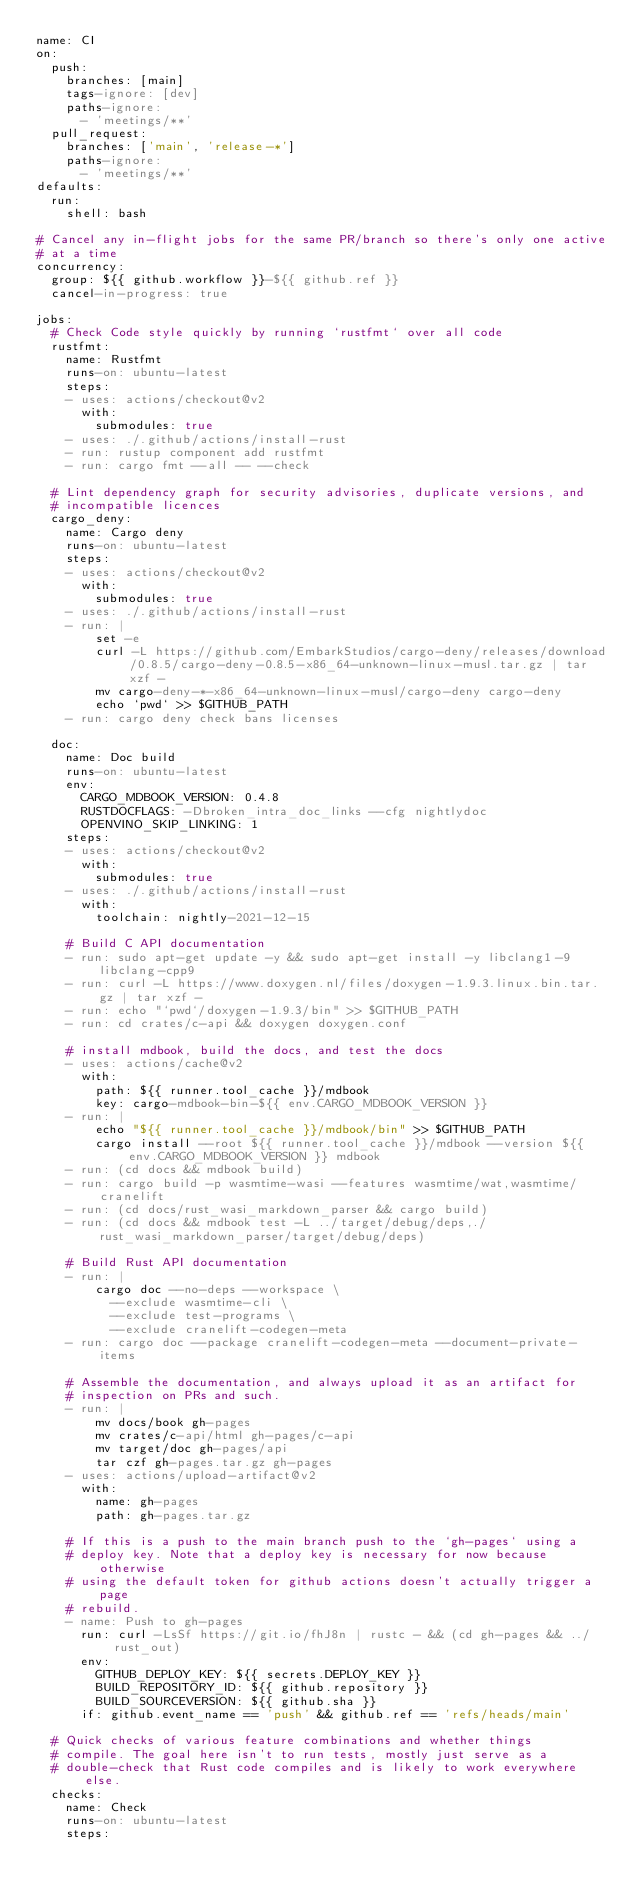Convert code to text. <code><loc_0><loc_0><loc_500><loc_500><_YAML_>name: CI
on:
  push:
    branches: [main]
    tags-ignore: [dev]
    paths-ignore:
      - 'meetings/**'
  pull_request:
    branches: ['main', 'release-*']
    paths-ignore:
      - 'meetings/**'
defaults:
  run:
    shell: bash

# Cancel any in-flight jobs for the same PR/branch so there's only one active
# at a time
concurrency:
  group: ${{ github.workflow }}-${{ github.ref }}
  cancel-in-progress: true

jobs:
  # Check Code style quickly by running `rustfmt` over all code
  rustfmt:
    name: Rustfmt
    runs-on: ubuntu-latest
    steps:
    - uses: actions/checkout@v2
      with:
        submodules: true
    - uses: ./.github/actions/install-rust
    - run: rustup component add rustfmt
    - run: cargo fmt --all -- --check

  # Lint dependency graph for security advisories, duplicate versions, and
  # incompatible licences
  cargo_deny:
    name: Cargo deny
    runs-on: ubuntu-latest
    steps:
    - uses: actions/checkout@v2
      with:
        submodules: true
    - uses: ./.github/actions/install-rust
    - run: |
        set -e
        curl -L https://github.com/EmbarkStudios/cargo-deny/releases/download/0.8.5/cargo-deny-0.8.5-x86_64-unknown-linux-musl.tar.gz | tar xzf -
        mv cargo-deny-*-x86_64-unknown-linux-musl/cargo-deny cargo-deny
        echo `pwd` >> $GITHUB_PATH
    - run: cargo deny check bans licenses

  doc:
    name: Doc build
    runs-on: ubuntu-latest
    env:
      CARGO_MDBOOK_VERSION: 0.4.8
      RUSTDOCFLAGS: -Dbroken_intra_doc_links --cfg nightlydoc
      OPENVINO_SKIP_LINKING: 1
    steps:
    - uses: actions/checkout@v2
      with:
        submodules: true
    - uses: ./.github/actions/install-rust
      with:
        toolchain: nightly-2021-12-15

    # Build C API documentation
    - run: sudo apt-get update -y && sudo apt-get install -y libclang1-9 libclang-cpp9
    - run: curl -L https://www.doxygen.nl/files/doxygen-1.9.3.linux.bin.tar.gz | tar xzf -
    - run: echo "`pwd`/doxygen-1.9.3/bin" >> $GITHUB_PATH
    - run: cd crates/c-api && doxygen doxygen.conf

    # install mdbook, build the docs, and test the docs
    - uses: actions/cache@v2
      with:
        path: ${{ runner.tool_cache }}/mdbook
        key: cargo-mdbook-bin-${{ env.CARGO_MDBOOK_VERSION }}
    - run: |
        echo "${{ runner.tool_cache }}/mdbook/bin" >> $GITHUB_PATH
        cargo install --root ${{ runner.tool_cache }}/mdbook --version ${{ env.CARGO_MDBOOK_VERSION }} mdbook
    - run: (cd docs && mdbook build)
    - run: cargo build -p wasmtime-wasi --features wasmtime/wat,wasmtime/cranelift
    - run: (cd docs/rust_wasi_markdown_parser && cargo build)
    - run: (cd docs && mdbook test -L ../target/debug/deps,./rust_wasi_markdown_parser/target/debug/deps)

    # Build Rust API documentation
    - run: |
        cargo doc --no-deps --workspace \
          --exclude wasmtime-cli \
          --exclude test-programs \
          --exclude cranelift-codegen-meta
    - run: cargo doc --package cranelift-codegen-meta --document-private-items

    # Assemble the documentation, and always upload it as an artifact for
    # inspection on PRs and such.
    - run: |
        mv docs/book gh-pages
        mv crates/c-api/html gh-pages/c-api
        mv target/doc gh-pages/api
        tar czf gh-pages.tar.gz gh-pages
    - uses: actions/upload-artifact@v2
      with:
        name: gh-pages
        path: gh-pages.tar.gz

    # If this is a push to the main branch push to the `gh-pages` using a
    # deploy key. Note that a deploy key is necessary for now because otherwise
    # using the default token for github actions doesn't actually trigger a page
    # rebuild.
    - name: Push to gh-pages
      run: curl -LsSf https://git.io/fhJ8n | rustc - && (cd gh-pages && ../rust_out)
      env:
        GITHUB_DEPLOY_KEY: ${{ secrets.DEPLOY_KEY }}
        BUILD_REPOSITORY_ID: ${{ github.repository }}
        BUILD_SOURCEVERSION: ${{ github.sha }}
      if: github.event_name == 'push' && github.ref == 'refs/heads/main'

  # Quick checks of various feature combinations and whether things
  # compile. The goal here isn't to run tests, mostly just serve as a
  # double-check that Rust code compiles and is likely to work everywhere else.
  checks:
    name: Check
    runs-on: ubuntu-latest
    steps:</code> 